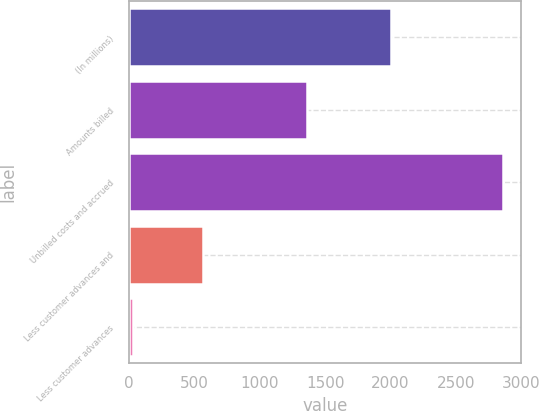Convert chart. <chart><loc_0><loc_0><loc_500><loc_500><bar_chart><fcel>(In millions)<fcel>Amounts billed<fcel>Unbilled costs and accrued<fcel>Less customer advances and<fcel>Less customer advances<nl><fcel>2005<fcel>1364<fcel>2858<fcel>563<fcel>28<nl></chart> 